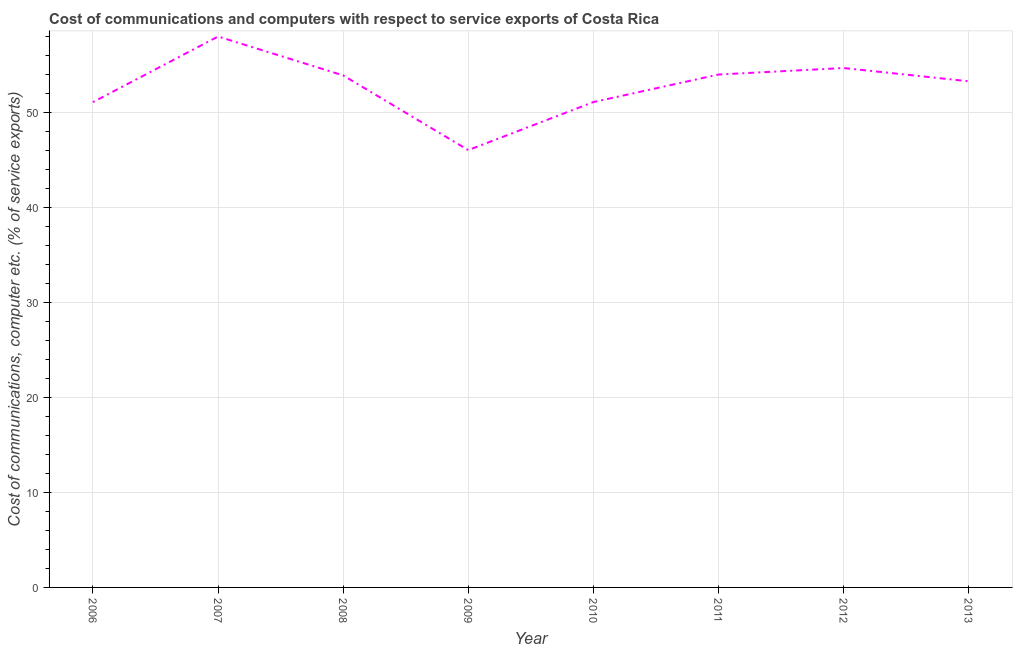What is the cost of communications and computer in 2007?
Make the answer very short. 58. Across all years, what is the maximum cost of communications and computer?
Give a very brief answer. 58. Across all years, what is the minimum cost of communications and computer?
Your answer should be very brief. 46.04. What is the sum of the cost of communications and computer?
Make the answer very short. 422.08. What is the difference between the cost of communications and computer in 2008 and 2013?
Your answer should be compact. 0.62. What is the average cost of communications and computer per year?
Your answer should be very brief. 52.76. What is the median cost of communications and computer?
Offer a terse response. 53.6. In how many years, is the cost of communications and computer greater than 8 %?
Give a very brief answer. 8. Do a majority of the years between 2006 and 2008 (inclusive) have cost of communications and computer greater than 24 %?
Your response must be concise. Yes. What is the ratio of the cost of communications and computer in 2012 to that in 2013?
Make the answer very short. 1.03. Is the cost of communications and computer in 2006 less than that in 2009?
Keep it short and to the point. No. Is the difference between the cost of communications and computer in 2006 and 2012 greater than the difference between any two years?
Make the answer very short. No. What is the difference between the highest and the second highest cost of communications and computer?
Give a very brief answer. 3.32. What is the difference between the highest and the lowest cost of communications and computer?
Provide a short and direct response. 11.96. In how many years, is the cost of communications and computer greater than the average cost of communications and computer taken over all years?
Your response must be concise. 5. Does the cost of communications and computer monotonically increase over the years?
Your response must be concise. No. How many lines are there?
Offer a very short reply. 1. How many years are there in the graph?
Your answer should be very brief. 8. What is the difference between two consecutive major ticks on the Y-axis?
Make the answer very short. 10. What is the title of the graph?
Give a very brief answer. Cost of communications and computers with respect to service exports of Costa Rica. What is the label or title of the Y-axis?
Your response must be concise. Cost of communications, computer etc. (% of service exports). What is the Cost of communications, computer etc. (% of service exports) in 2006?
Your response must be concise. 51.09. What is the Cost of communications, computer etc. (% of service exports) of 2007?
Your answer should be very brief. 58. What is the Cost of communications, computer etc. (% of service exports) in 2008?
Provide a short and direct response. 53.91. What is the Cost of communications, computer etc. (% of service exports) in 2009?
Your answer should be very brief. 46.04. What is the Cost of communications, computer etc. (% of service exports) of 2010?
Your response must be concise. 51.09. What is the Cost of communications, computer etc. (% of service exports) of 2011?
Provide a succinct answer. 53.99. What is the Cost of communications, computer etc. (% of service exports) of 2012?
Offer a terse response. 54.68. What is the Cost of communications, computer etc. (% of service exports) of 2013?
Offer a terse response. 53.29. What is the difference between the Cost of communications, computer etc. (% of service exports) in 2006 and 2007?
Give a very brief answer. -6.91. What is the difference between the Cost of communications, computer etc. (% of service exports) in 2006 and 2008?
Provide a short and direct response. -2.82. What is the difference between the Cost of communications, computer etc. (% of service exports) in 2006 and 2009?
Give a very brief answer. 5.05. What is the difference between the Cost of communications, computer etc. (% of service exports) in 2006 and 2010?
Keep it short and to the point. -0.01. What is the difference between the Cost of communications, computer etc. (% of service exports) in 2006 and 2011?
Your response must be concise. -2.91. What is the difference between the Cost of communications, computer etc. (% of service exports) in 2006 and 2012?
Your answer should be compact. -3.59. What is the difference between the Cost of communications, computer etc. (% of service exports) in 2006 and 2013?
Your response must be concise. -2.2. What is the difference between the Cost of communications, computer etc. (% of service exports) in 2007 and 2008?
Offer a terse response. 4.09. What is the difference between the Cost of communications, computer etc. (% of service exports) in 2007 and 2009?
Offer a very short reply. 11.96. What is the difference between the Cost of communications, computer etc. (% of service exports) in 2007 and 2010?
Offer a terse response. 6.9. What is the difference between the Cost of communications, computer etc. (% of service exports) in 2007 and 2011?
Your response must be concise. 4. What is the difference between the Cost of communications, computer etc. (% of service exports) in 2007 and 2012?
Provide a succinct answer. 3.32. What is the difference between the Cost of communications, computer etc. (% of service exports) in 2007 and 2013?
Give a very brief answer. 4.71. What is the difference between the Cost of communications, computer etc. (% of service exports) in 2008 and 2009?
Your response must be concise. 7.87. What is the difference between the Cost of communications, computer etc. (% of service exports) in 2008 and 2010?
Offer a very short reply. 2.81. What is the difference between the Cost of communications, computer etc. (% of service exports) in 2008 and 2011?
Offer a terse response. -0.09. What is the difference between the Cost of communications, computer etc. (% of service exports) in 2008 and 2012?
Your answer should be compact. -0.77. What is the difference between the Cost of communications, computer etc. (% of service exports) in 2008 and 2013?
Give a very brief answer. 0.62. What is the difference between the Cost of communications, computer etc. (% of service exports) in 2009 and 2010?
Provide a succinct answer. -5.06. What is the difference between the Cost of communications, computer etc. (% of service exports) in 2009 and 2011?
Ensure brevity in your answer.  -7.96. What is the difference between the Cost of communications, computer etc. (% of service exports) in 2009 and 2012?
Make the answer very short. -8.64. What is the difference between the Cost of communications, computer etc. (% of service exports) in 2009 and 2013?
Offer a terse response. -7.25. What is the difference between the Cost of communications, computer etc. (% of service exports) in 2010 and 2011?
Ensure brevity in your answer.  -2.9. What is the difference between the Cost of communications, computer etc. (% of service exports) in 2010 and 2012?
Your answer should be very brief. -3.59. What is the difference between the Cost of communications, computer etc. (% of service exports) in 2010 and 2013?
Make the answer very short. -2.19. What is the difference between the Cost of communications, computer etc. (% of service exports) in 2011 and 2012?
Provide a succinct answer. -0.68. What is the difference between the Cost of communications, computer etc. (% of service exports) in 2011 and 2013?
Give a very brief answer. 0.71. What is the difference between the Cost of communications, computer etc. (% of service exports) in 2012 and 2013?
Offer a very short reply. 1.39. What is the ratio of the Cost of communications, computer etc. (% of service exports) in 2006 to that in 2007?
Make the answer very short. 0.88. What is the ratio of the Cost of communications, computer etc. (% of service exports) in 2006 to that in 2008?
Ensure brevity in your answer.  0.95. What is the ratio of the Cost of communications, computer etc. (% of service exports) in 2006 to that in 2009?
Provide a succinct answer. 1.11. What is the ratio of the Cost of communications, computer etc. (% of service exports) in 2006 to that in 2011?
Offer a terse response. 0.95. What is the ratio of the Cost of communications, computer etc. (% of service exports) in 2006 to that in 2012?
Ensure brevity in your answer.  0.93. What is the ratio of the Cost of communications, computer etc. (% of service exports) in 2006 to that in 2013?
Give a very brief answer. 0.96. What is the ratio of the Cost of communications, computer etc. (% of service exports) in 2007 to that in 2008?
Give a very brief answer. 1.08. What is the ratio of the Cost of communications, computer etc. (% of service exports) in 2007 to that in 2009?
Give a very brief answer. 1.26. What is the ratio of the Cost of communications, computer etc. (% of service exports) in 2007 to that in 2010?
Offer a terse response. 1.14. What is the ratio of the Cost of communications, computer etc. (% of service exports) in 2007 to that in 2011?
Your response must be concise. 1.07. What is the ratio of the Cost of communications, computer etc. (% of service exports) in 2007 to that in 2012?
Provide a succinct answer. 1.06. What is the ratio of the Cost of communications, computer etc. (% of service exports) in 2007 to that in 2013?
Give a very brief answer. 1.09. What is the ratio of the Cost of communications, computer etc. (% of service exports) in 2008 to that in 2009?
Keep it short and to the point. 1.17. What is the ratio of the Cost of communications, computer etc. (% of service exports) in 2008 to that in 2010?
Your response must be concise. 1.05. What is the ratio of the Cost of communications, computer etc. (% of service exports) in 2008 to that in 2013?
Your answer should be very brief. 1.01. What is the ratio of the Cost of communications, computer etc. (% of service exports) in 2009 to that in 2010?
Provide a short and direct response. 0.9. What is the ratio of the Cost of communications, computer etc. (% of service exports) in 2009 to that in 2011?
Provide a short and direct response. 0.85. What is the ratio of the Cost of communications, computer etc. (% of service exports) in 2009 to that in 2012?
Offer a terse response. 0.84. What is the ratio of the Cost of communications, computer etc. (% of service exports) in 2009 to that in 2013?
Your answer should be very brief. 0.86. What is the ratio of the Cost of communications, computer etc. (% of service exports) in 2010 to that in 2011?
Offer a terse response. 0.95. What is the ratio of the Cost of communications, computer etc. (% of service exports) in 2010 to that in 2012?
Offer a terse response. 0.93. What is the ratio of the Cost of communications, computer etc. (% of service exports) in 2010 to that in 2013?
Offer a very short reply. 0.96. What is the ratio of the Cost of communications, computer etc. (% of service exports) in 2011 to that in 2013?
Ensure brevity in your answer.  1.01. What is the ratio of the Cost of communications, computer etc. (% of service exports) in 2012 to that in 2013?
Provide a short and direct response. 1.03. 